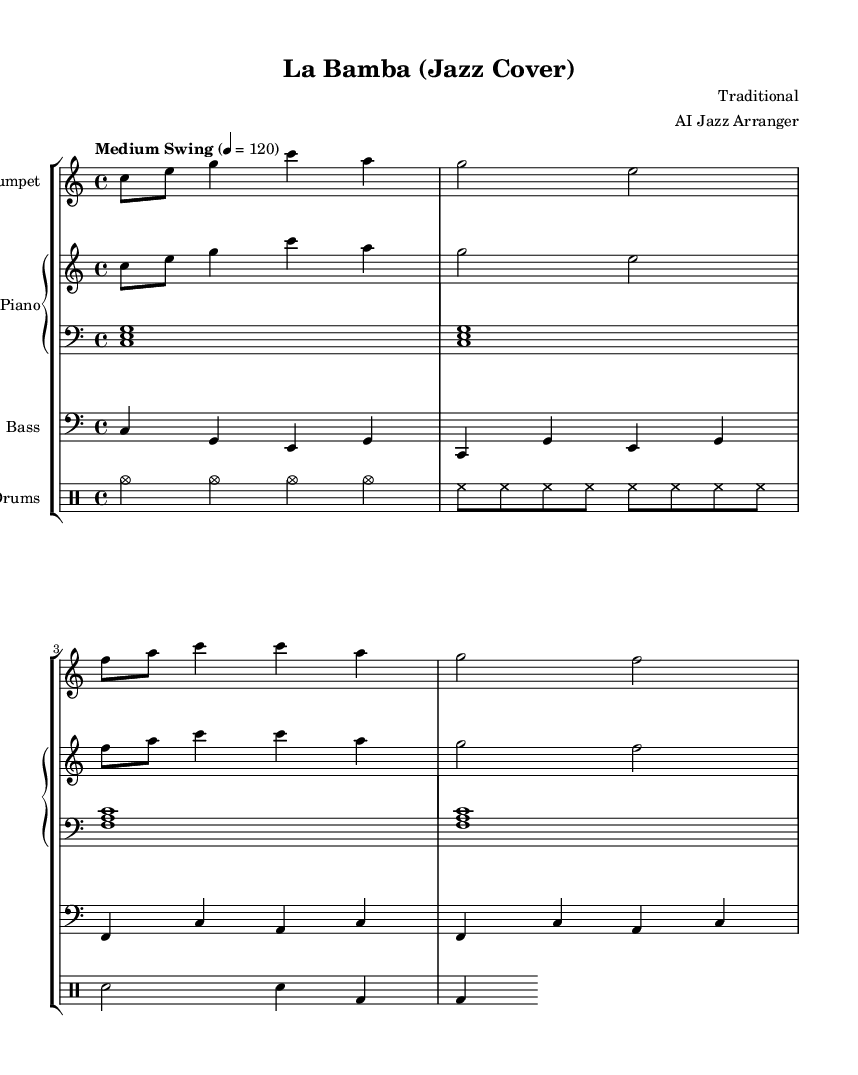What is the key signature of this music? The key signature is C major, which has no sharps or flats.
Answer: C major What is the time signature of the piece? The time signature is indicated as 4/4, which means four beats per measure and the quarter note gets one beat.
Answer: 4/4 What is the tempo marking for this piece? The tempo marking shows "Medium Swing" at a speed of 120 beats per minute, which indicates the feel of the rhythm.
Answer: Medium Swing 120 How many measures are in the trumpet part? Counting the measures in the trumpet part, there are a total of 4 measures present in the provided music.
Answer: 4 What is the main rhythmic style evidenced in this music? The music features a "swing" feel, common in jazz, where the eighth notes unevenly alternate creating a relaxed groove.
Answer: Swing What are the instruments included in this jazz arrangement? The arrangement consists of trumpet, piano (both right and left hand), bass, and drums, which are typical instruments for a jazz ensemble.
Answer: Trumpet, Piano, Bass, Drums What is the role of the bass in jazz music as suggested by this arrangement? The bass typically outlines the harmonic structure and provides rhythmic foundation, which is evidenced in the bass music consisting of root notes with rhythmic patterns.
Answer: Harmonic foundation 